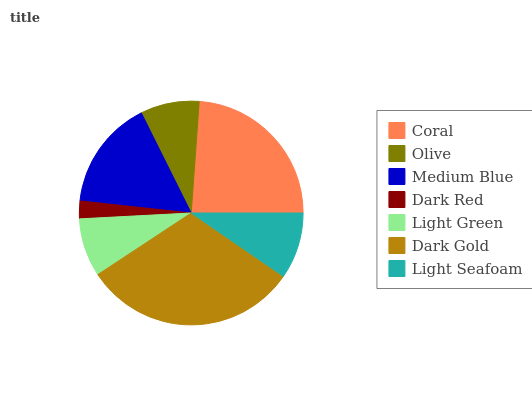Is Dark Red the minimum?
Answer yes or no. Yes. Is Dark Gold the maximum?
Answer yes or no. Yes. Is Olive the minimum?
Answer yes or no. No. Is Olive the maximum?
Answer yes or no. No. Is Coral greater than Olive?
Answer yes or no. Yes. Is Olive less than Coral?
Answer yes or no. Yes. Is Olive greater than Coral?
Answer yes or no. No. Is Coral less than Olive?
Answer yes or no. No. Is Light Seafoam the high median?
Answer yes or no. Yes. Is Light Seafoam the low median?
Answer yes or no. Yes. Is Light Green the high median?
Answer yes or no. No. Is Medium Blue the low median?
Answer yes or no. No. 